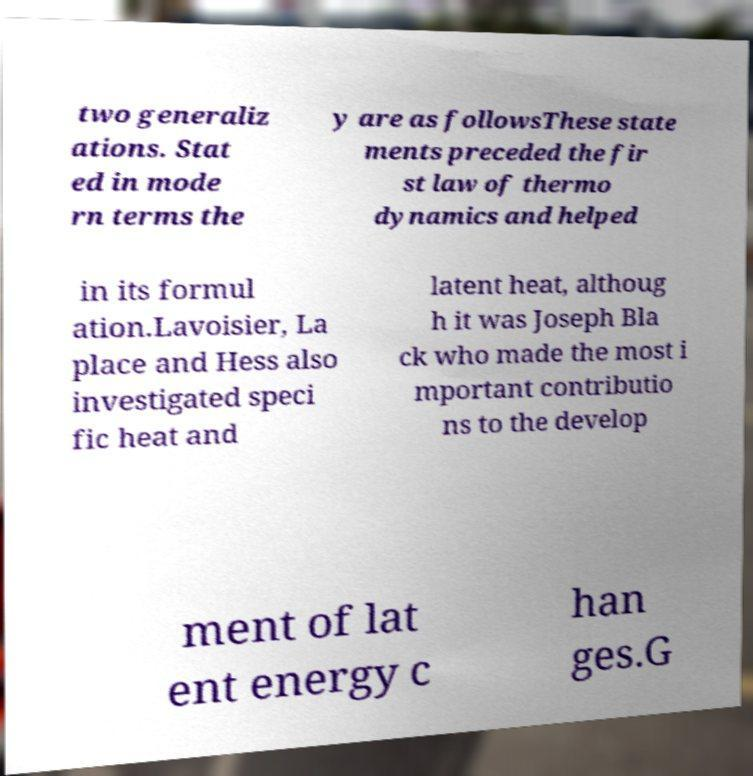There's text embedded in this image that I need extracted. Can you transcribe it verbatim? two generaliz ations. Stat ed in mode rn terms the y are as followsThese state ments preceded the fir st law of thermo dynamics and helped in its formul ation.Lavoisier, La place and Hess also investigated speci fic heat and latent heat, althoug h it was Joseph Bla ck who made the most i mportant contributio ns to the develop ment of lat ent energy c han ges.G 